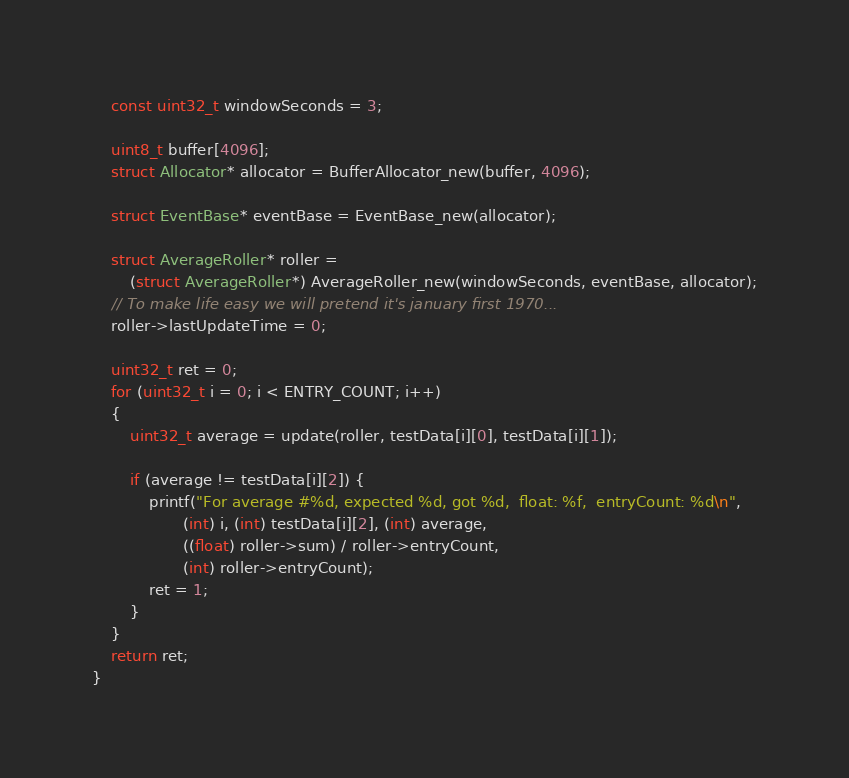Convert code to text. <code><loc_0><loc_0><loc_500><loc_500><_C_>    const uint32_t windowSeconds = 3;

    uint8_t buffer[4096];
    struct Allocator* allocator = BufferAllocator_new(buffer, 4096);

    struct EventBase* eventBase = EventBase_new(allocator);

    struct AverageRoller* roller =
        (struct AverageRoller*) AverageRoller_new(windowSeconds, eventBase, allocator);
    // To make life easy we will pretend it's january first 1970...
    roller->lastUpdateTime = 0;

    uint32_t ret = 0;
    for (uint32_t i = 0; i < ENTRY_COUNT; i++)
    {
        uint32_t average = update(roller, testData[i][0], testData[i][1]);

        if (average != testData[i][2]) {
            printf("For average #%d, expected %d, got %d,  float: %f,  entryCount: %d\n",
                   (int) i, (int) testData[i][2], (int) average,
                   ((float) roller->sum) / roller->entryCount,
                   (int) roller->entryCount);
            ret = 1;
        }
    }
    return ret;
}
</code> 